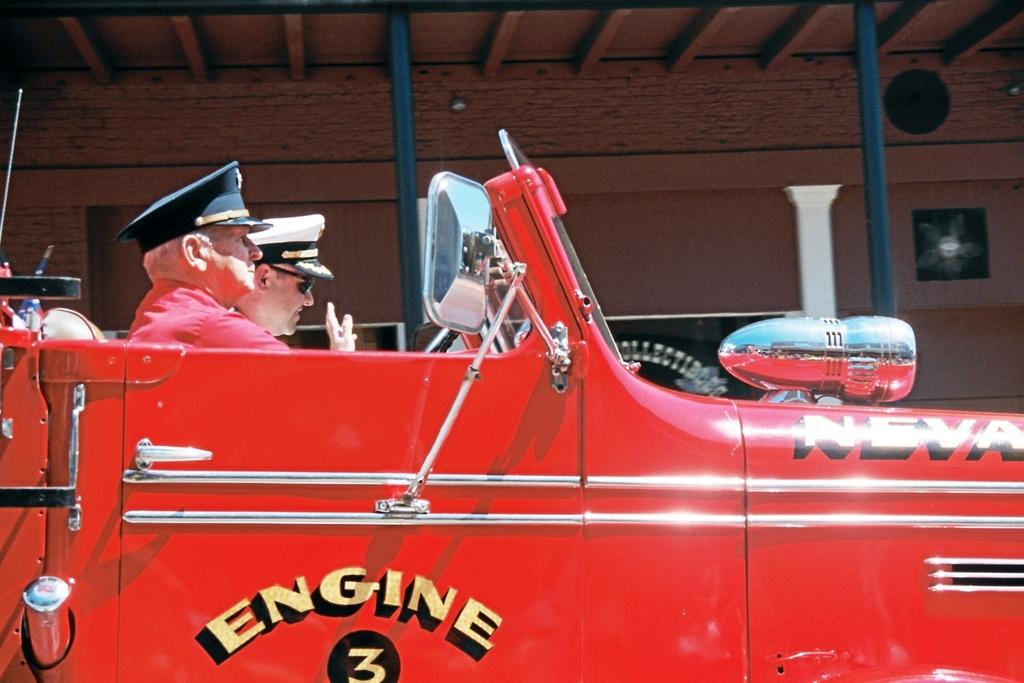How many people are in the vehicle in the image? There are two men in the vehicle. What can be seen on the right side of the image? There is a fan and a wall on the right side of the image. Who is the aunt of the person driving the vehicle in the image? There is no information about an aunt or any family members in the image. 